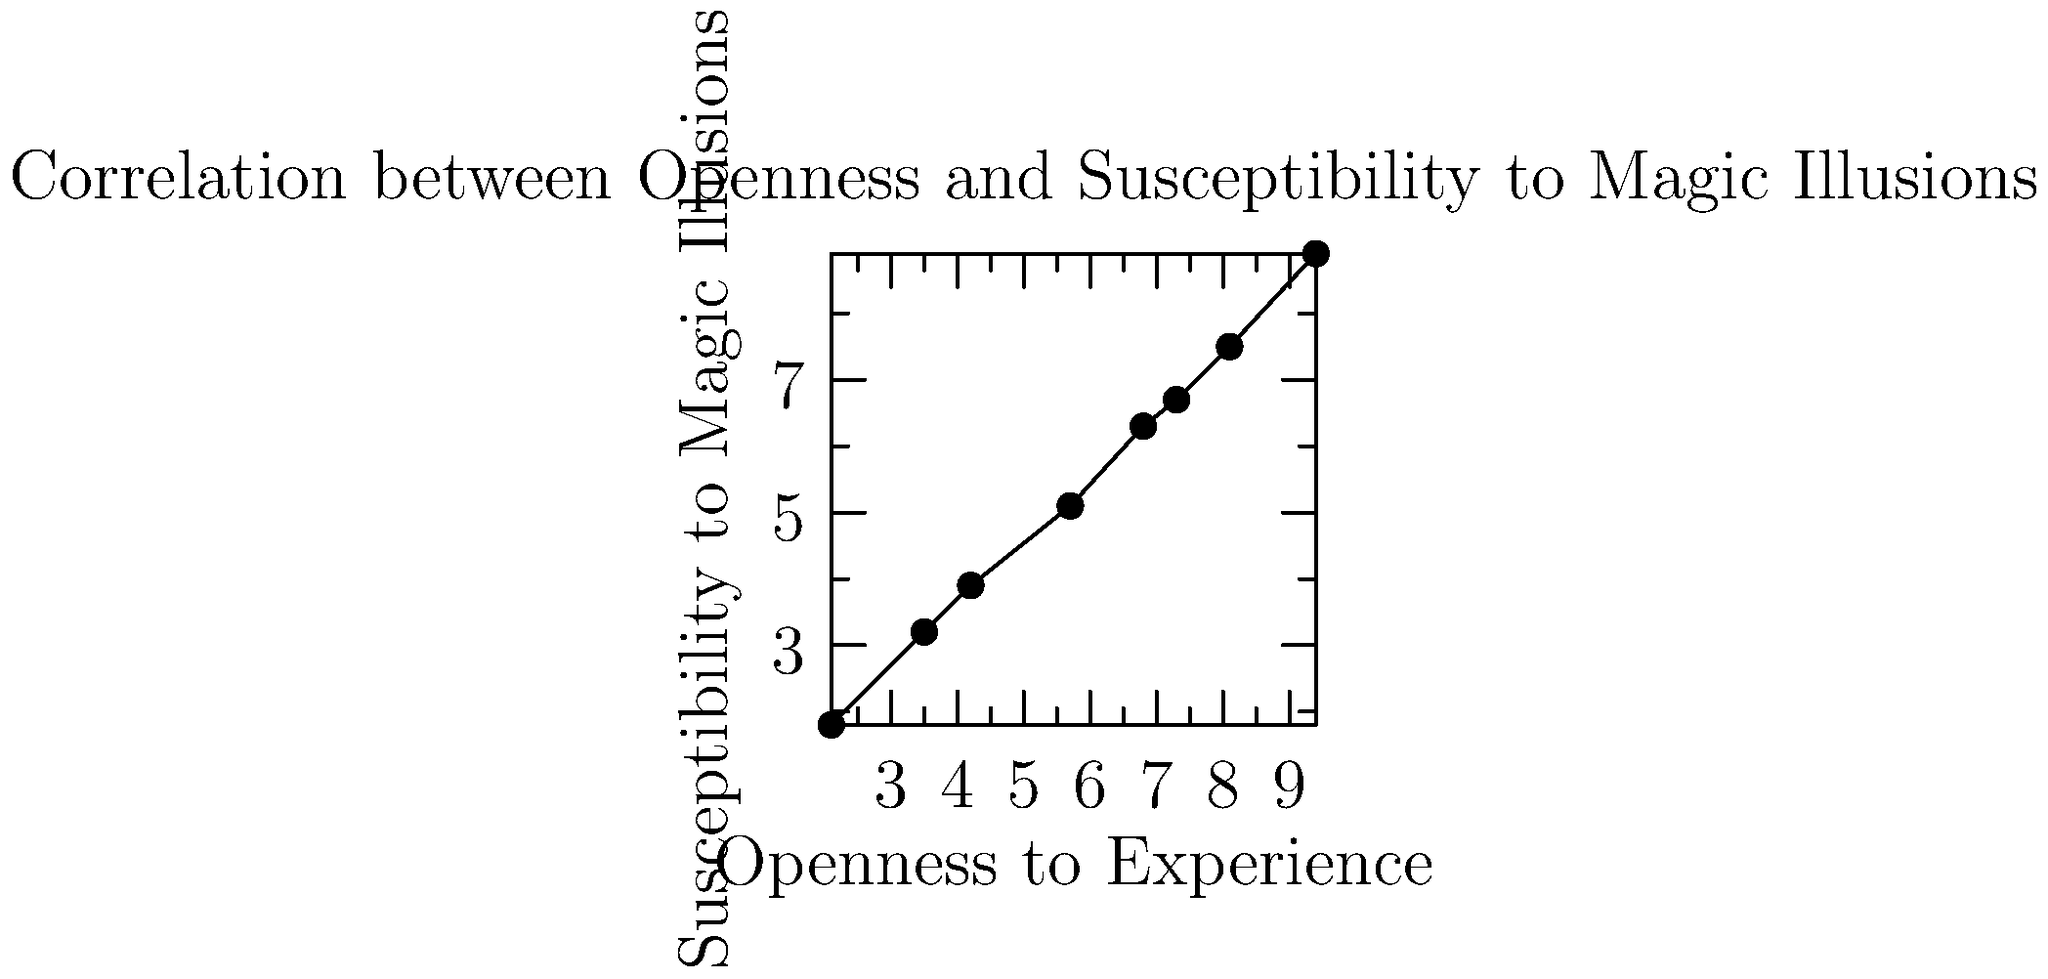Based on the scatter plot showing the relationship between Openness to Experience and Susceptibility to Magic Illusions, what type of correlation is observed between these two variables? To determine the type of correlation between Openness to Experience and Susceptibility to Magic Illusions, we need to analyze the pattern of the data points in the scatter plot:

1. Direction: As we move from left to right (increasing Openness to Experience), we can see that the data points generally move upward (increasing Susceptibility to Magic Illusions).

2. Strength: The data points form a fairly tight pattern around an imaginary line that could be drawn through them.

3. Linearity: The relationship appears to be roughly linear, with no obvious curves or bends in the pattern.

4. Consistency: There are no significant outliers or clusters that deviate from the general trend.

Given these observations, we can conclude that there is a positive correlation between Openness to Experience and Susceptibility to Magic Illusions. The correlation appears to be strong and linear.

In statistical terms, this type of relationship would typically be described as a strong positive linear correlation.
Answer: Strong positive linear correlation 